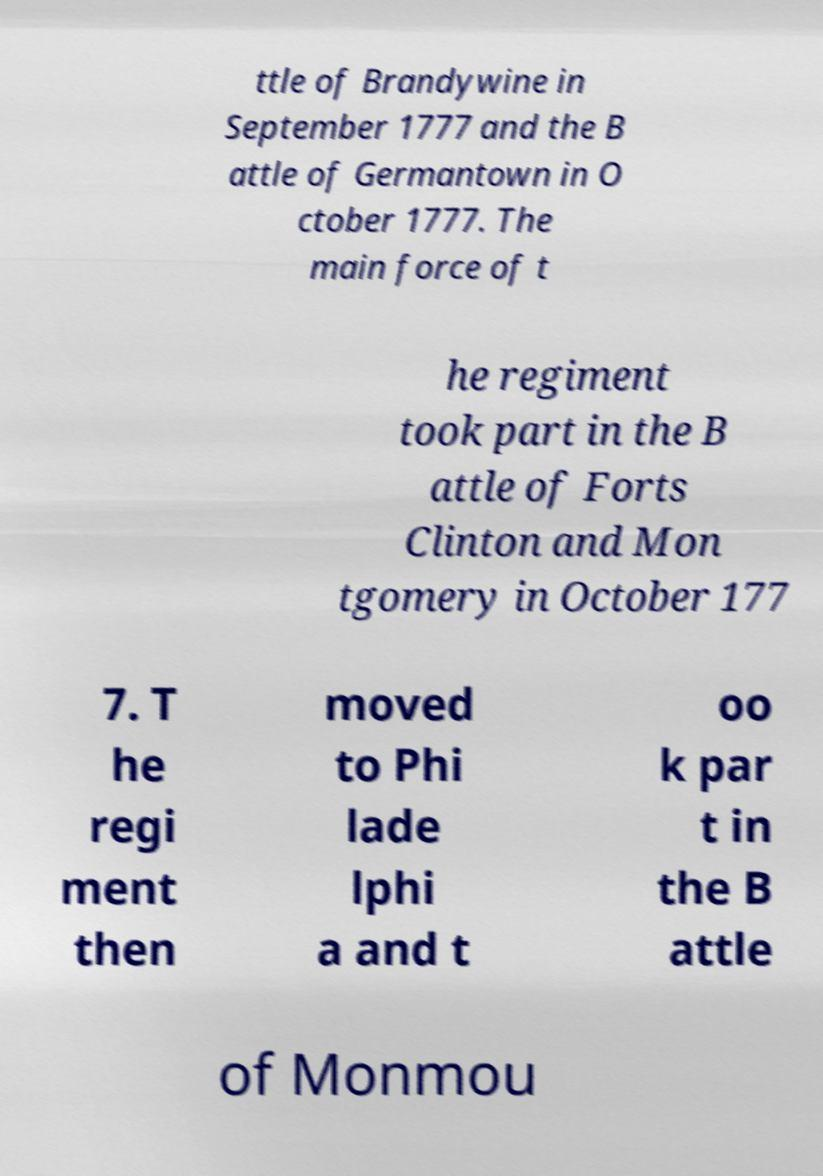Could you assist in decoding the text presented in this image and type it out clearly? ttle of Brandywine in September 1777 and the B attle of Germantown in O ctober 1777. The main force of t he regiment took part in the B attle of Forts Clinton and Mon tgomery in October 177 7. T he regi ment then moved to Phi lade lphi a and t oo k par t in the B attle of Monmou 